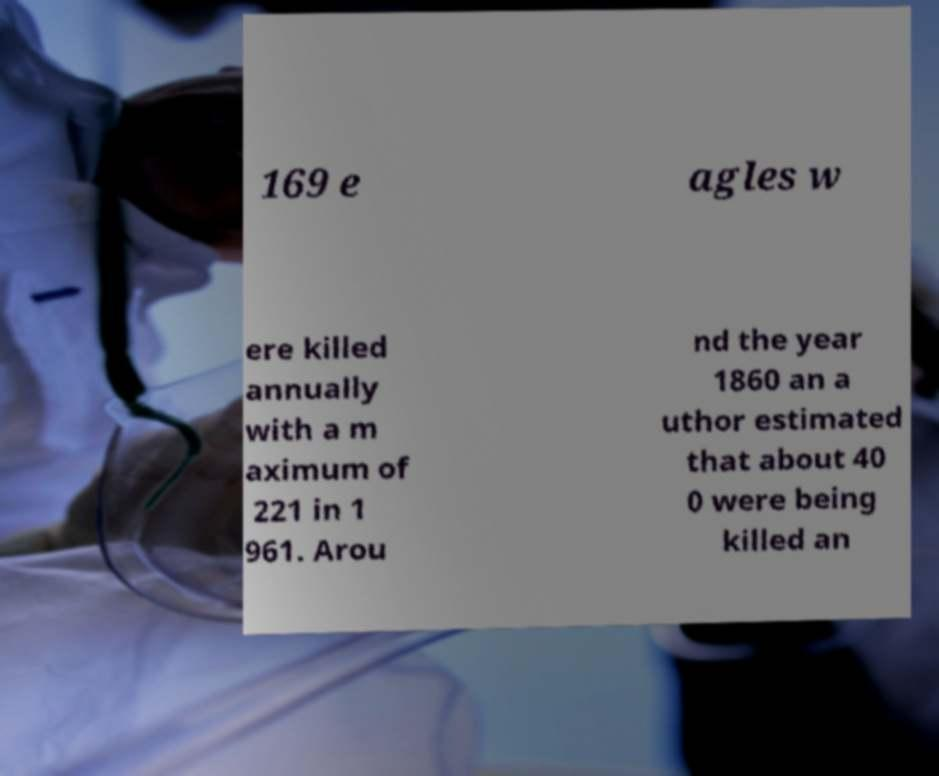What messages or text are displayed in this image? I need them in a readable, typed format. 169 e agles w ere killed annually with a m aximum of 221 in 1 961. Arou nd the year 1860 an a uthor estimated that about 40 0 were being killed an 